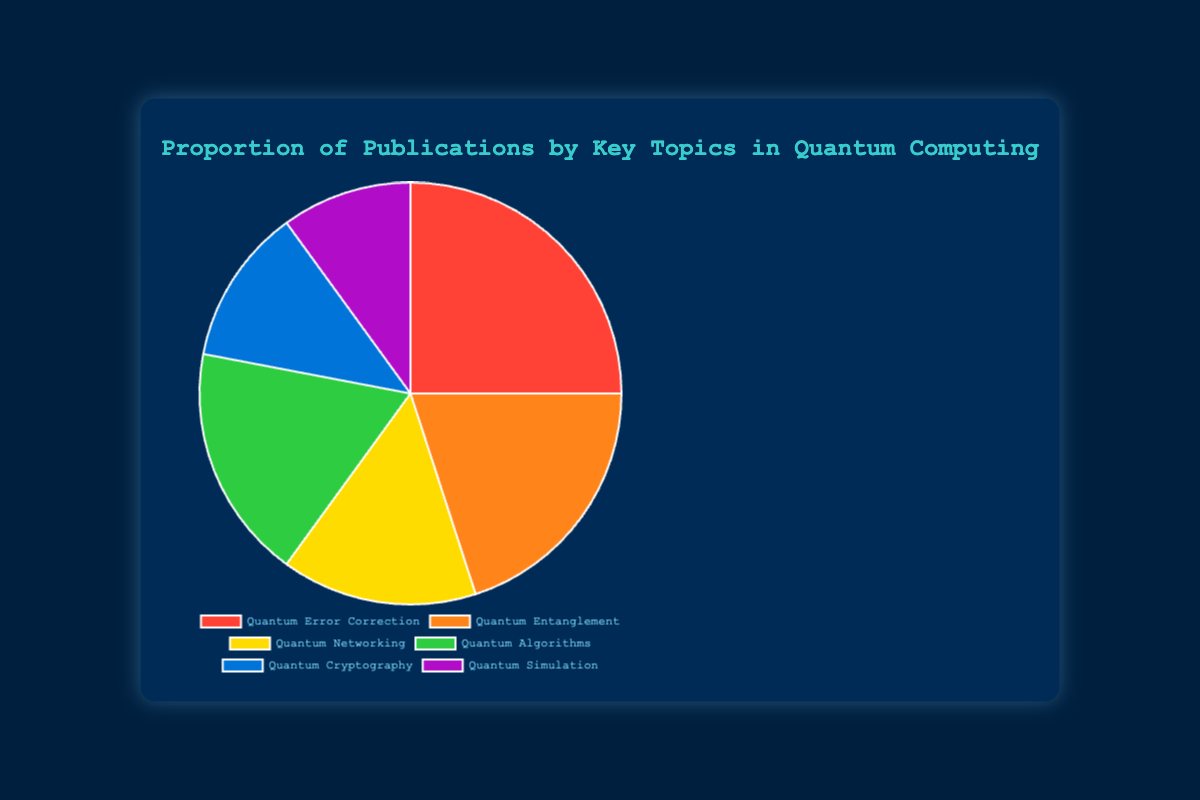Which topic has the highest proportion of publications? The topic with the highest proportion of publications is Quantum Error Correction, as it takes up the largest slice of the pie chart at 25%.
Answer: Quantum Error Correction What's the combined percentage of publications for Quantum Entanglement and Quantum Algorithms? The percentage of publications for Quantum Entanglement is 20% and for Quantum Algorithms is 18%. Adding these together gives 20% + 18% = 38%.
Answer: 38% How does the proportion of publications on Quantum Networking compare to Quantum Cryptography? Quantum Networking has a proportion of 15%, while Quantum Cryptography has 12%. Comparing these, Quantum Networking has a higher proportion of publications by 3%.
Answer: Quantum Networking Which topic has the smallest proportion of publications, and what is this proportion? The topic with the smallest proportion of publications is Quantum Simulation, as it occupies the smallest slice of the pie chart at 10%.
Answer: Quantum Simulation What's the total percentage of publications dedicated to topics other than Quantum Error Correction? The percentage for Quantum Error Correction is 25%. Subtracting this from 100% gives 100% - 25% = 75%.
Answer: 75% What is the difference in publication proportion between the top two topics? The top two topics are Quantum Error Correction (25%) and Quantum Entanglement (20%). The difference between them is 25% - 20% = 5%.
Answer: 5% What color represents Quantum Cryptography on the chart? The color representing Quantum Cryptography is blue.
Answer: blue Which topics together make up more than half of the total publications? The topics Quantum Error Correction (25%), Quantum Entanglement (20%), and Quantum Algorithms (18%) together make up 63%, which is more than half of the total.
Answer: Quantum Error Correction, Quantum Entanglement, Quantum Algorithms What is the average proportion of publications across all topics? The proportions are 25%, 20%, 15%, 18%, 12%, and 10%. Adding these gives 25% + 20% + 15% + 18% + 12% + 10% = 100%. There are 6 topics, so the average is 100% / 6 = 16.67%.
Answer: 16.67% If the percentage of publications for Quantum Algorithms were doubled, what would be its new proportion? The current proportion for Quantum Algorithms is 18%. Doubling this proportion gives 18% * 2 = 36%.
Answer: 36% 